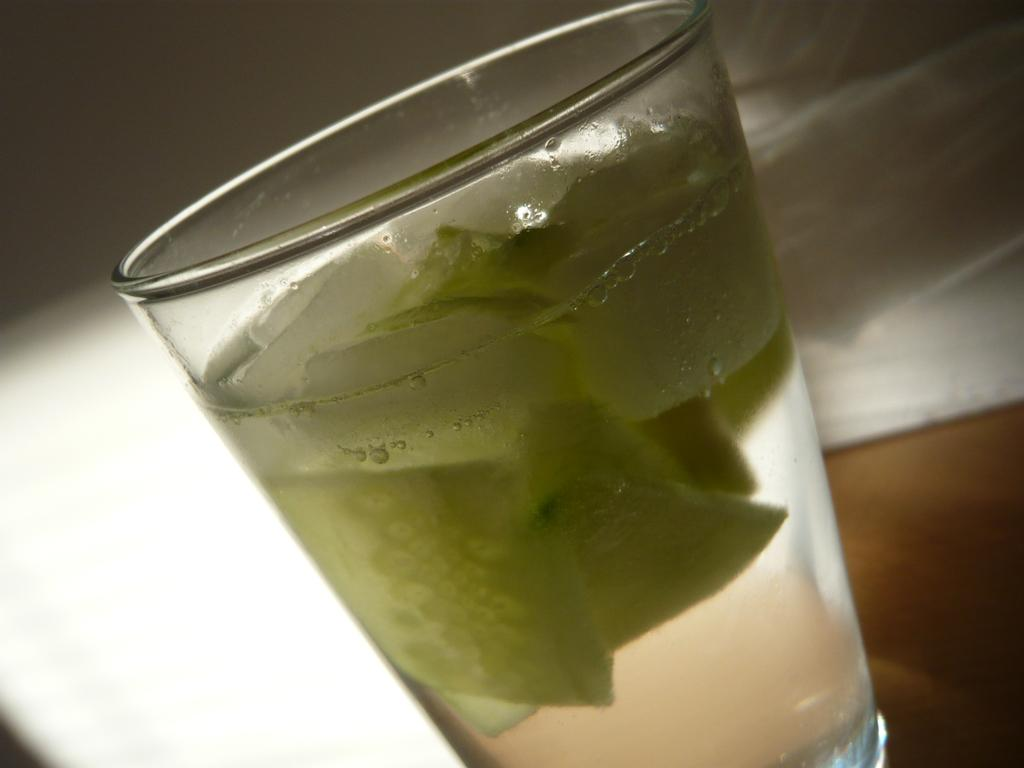What object in the image is used for holding liquids? There is a glass in the image that is used for holding liquids. What is inside the glass? The glass contains a drink. What type of hole can be seen in the bedroom in the image? There is no bedroom or hole present in the image; it only features a glass containing a drink. 